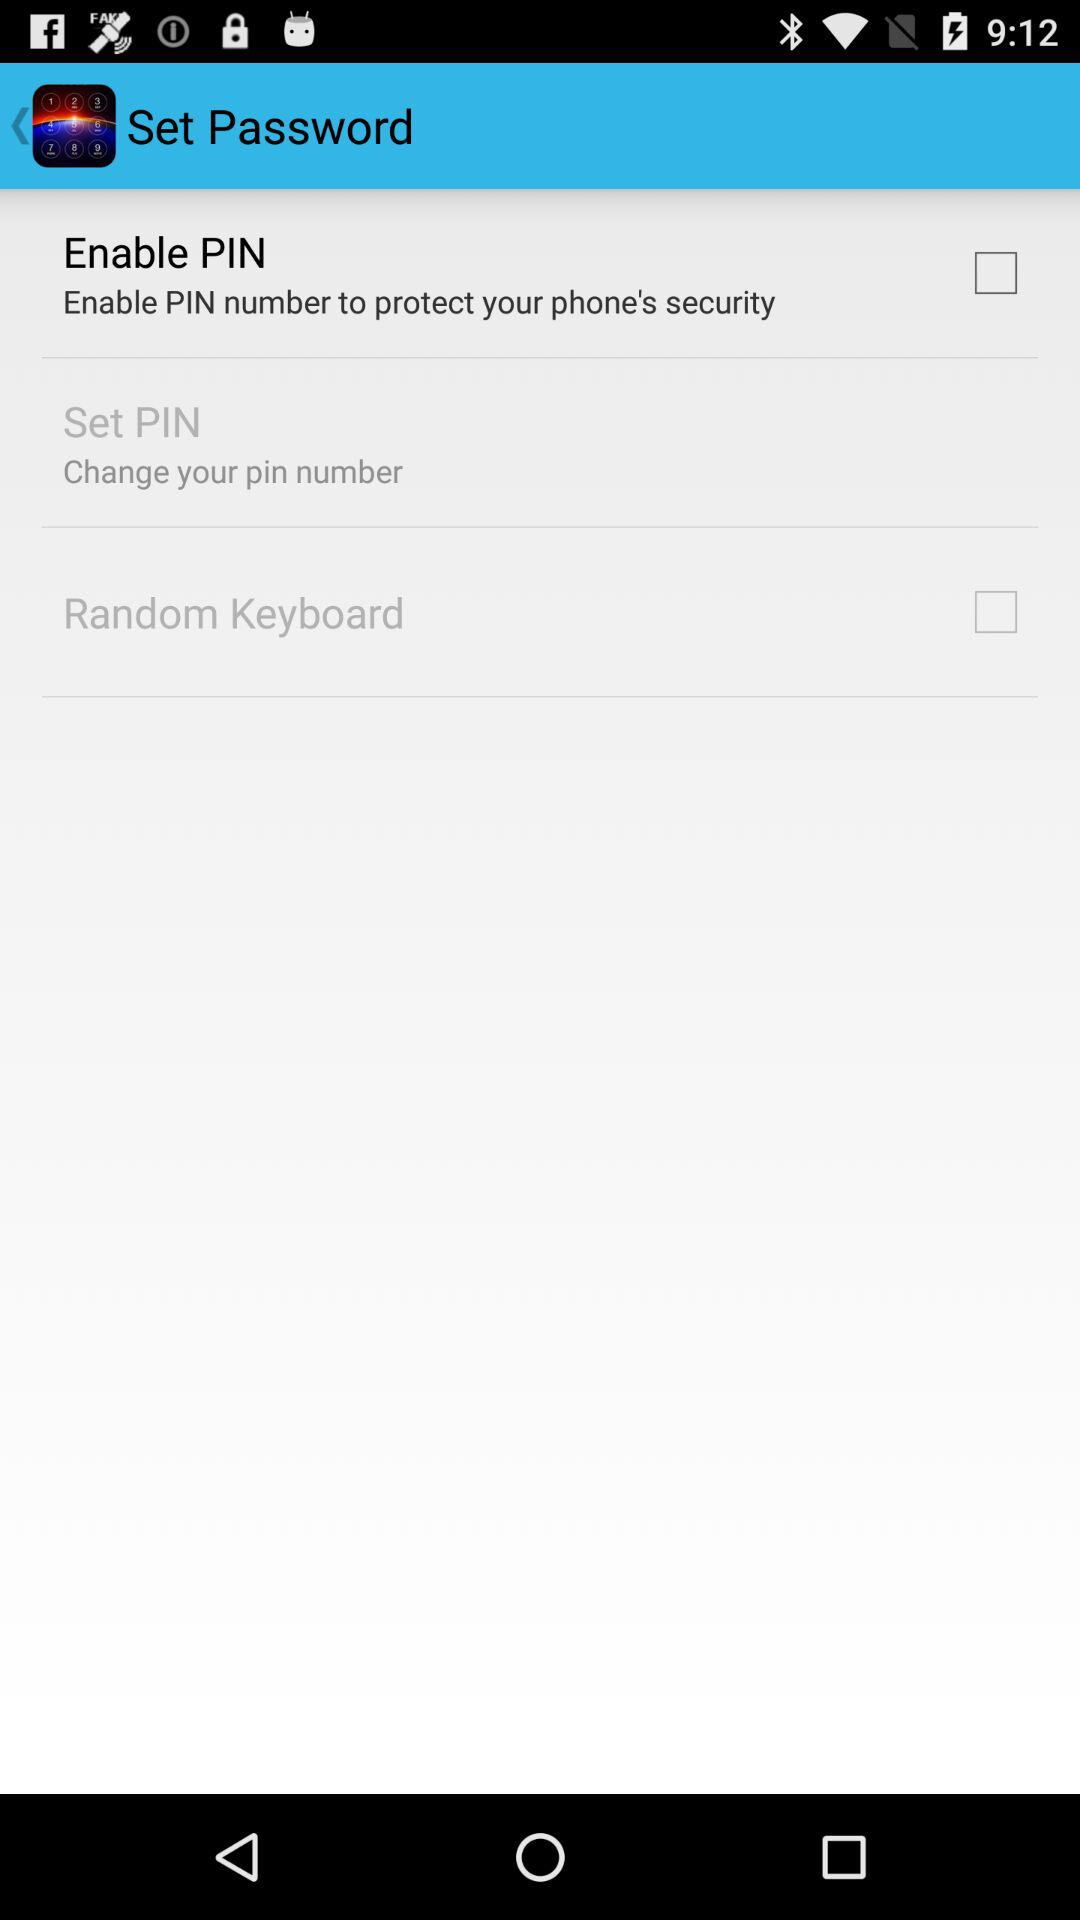What is the name of the application? The application is "Set Password". 